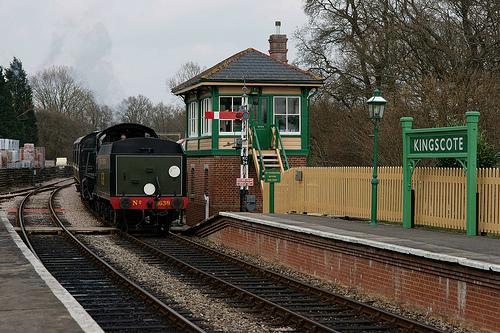Question: what vehicle is shown?
Choices:
A. Bus.
B. Truck.
C. Subway.
D. Train.
Answer with the letter. Answer: D Question: who can be seen?
Choices:
A. No one.
B. The butcher.
C. The Baker.
D. The Candle Stick Maker.
Answer with the letter. Answer: A Question: what color is the sign?
Choices:
A. Red.
B. Green.
C. Black and yellow.
D. White.
Answer with the letter. Answer: B Question: what does the sign say?
Choices:
A. Sidney.
B. Brisbane.
C. Kingscote.
D. Melbourne.
Answer with the letter. Answer: C Question: what color is the fence?
Choices:
A. Brown.
B. Green.
C. Black.
D. White.
Answer with the letter. Answer: A 